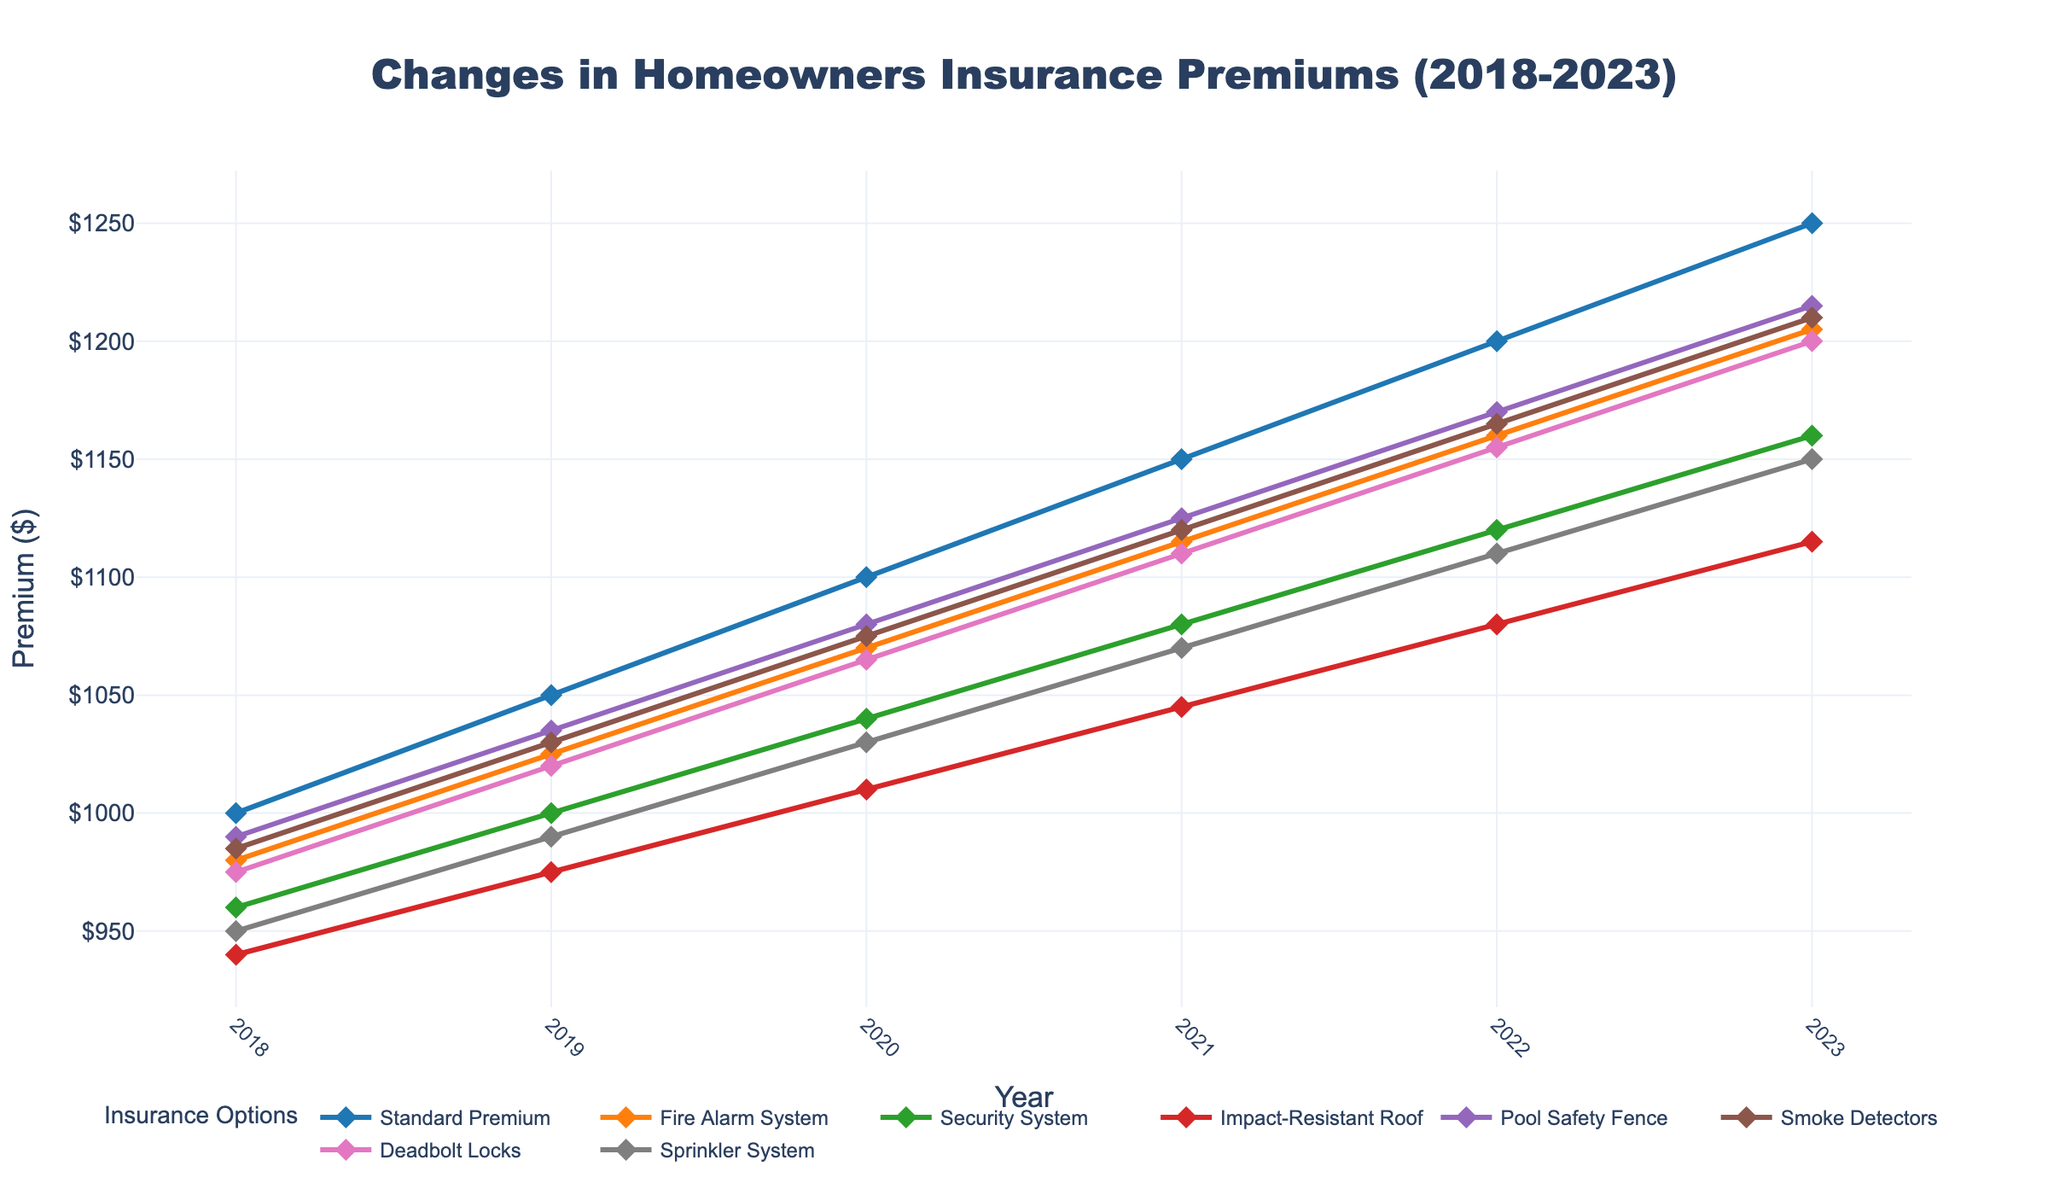What was the premium cost for a homeowner with an Impact-Resistant Roof in 2020? Locate the 'Impact-Resistant Roof' line and follow it to the year 2020. The value at the intersection is the premium cost for that year.
Answer: 1010 How much did the standard premium increase from 2018 to 2023? Find the 'Standard Premium' values for 2018 and 2023, then subtract the 2018 value from the 2023 value: 1250 - 1000 = 250
Answer: 250 Which safety upgrade had the highest premium in 2023? Look at the premiums for all safety upgrades in 2023 and identify the highest value. The 'Fire Alarm System' has the highest premium in 2023 at $1205.
Answer: Fire Alarm System Compare the 2021 premiums for Security System and Smoke Detectors. Which one is higher? Find the 2021 values for both 'Security System' and 'Smoke Detectors'. The 'Smoke Detectors' premium is 1120, while 'Security System' is 1080. Therefore, Smoke Detectors is higher.
Answer: Smoke Detectors What is the average premium for Deadbolt Locks over the years shown? Calculate the average of Deadbolt Locks' premiums: (975 + 1020 + 1065 + 1110 + 1155 + 1200)/6 = 1087.5
Answer: 1087.5 Between 2019 and 2022, which safety upgrade shows the smallest increase in premium? Calculate the increase for each safety upgrade: 
Fire Alarm System (1160-1025)=135,
Security System (1120-1000)=120,
Impact-Resistant Roof (1080-975)=105,
Pool Safety Fence (1170-1035)=135,
Smoke Detectors (1165-1030)=135,
Deadbolt Locks (1155-1020)=135,
Sprinkler System (1110-990)=120.
Therefore, Impact-Resistant Roof has the smallest increase.
Answer: Impact-Resistant Roof How does the premium for a Pool Safety Fence in 2023 compare to the Standard Premium in 2019? Find the values for 'Pool Safety Fence' in 2023 and 'Standard Premium' in 2019. Pool Safety Fence in 2023 is 1215, and Standard Premium in 2019 is 1050. Therefore, Pool Safety Fence in 2023 is higher.
Answer: Pool Safety Fence in 2023 is higher If a homeowner had Smoke Detectors in 2018 and added Deadbolt Locks in 2022, what would be the combined increase in their premium? Calculate the increase in Smoke Detectors: 2018 to 2022 as 1165-985=180. Similarly, for Deadbolt Locks: 975 to 1155, an increase of 180. Add the increases for the combined increase: 180+180=360
Answer: 360 Which safety upgrade's premium had the steadiest increase over the years 2018 to 2023? Compare the trajectories of each line. The 'Impact-Resistant Roof' shows a consistent and steady increase.
Answer: Impact-Resistant Roof 